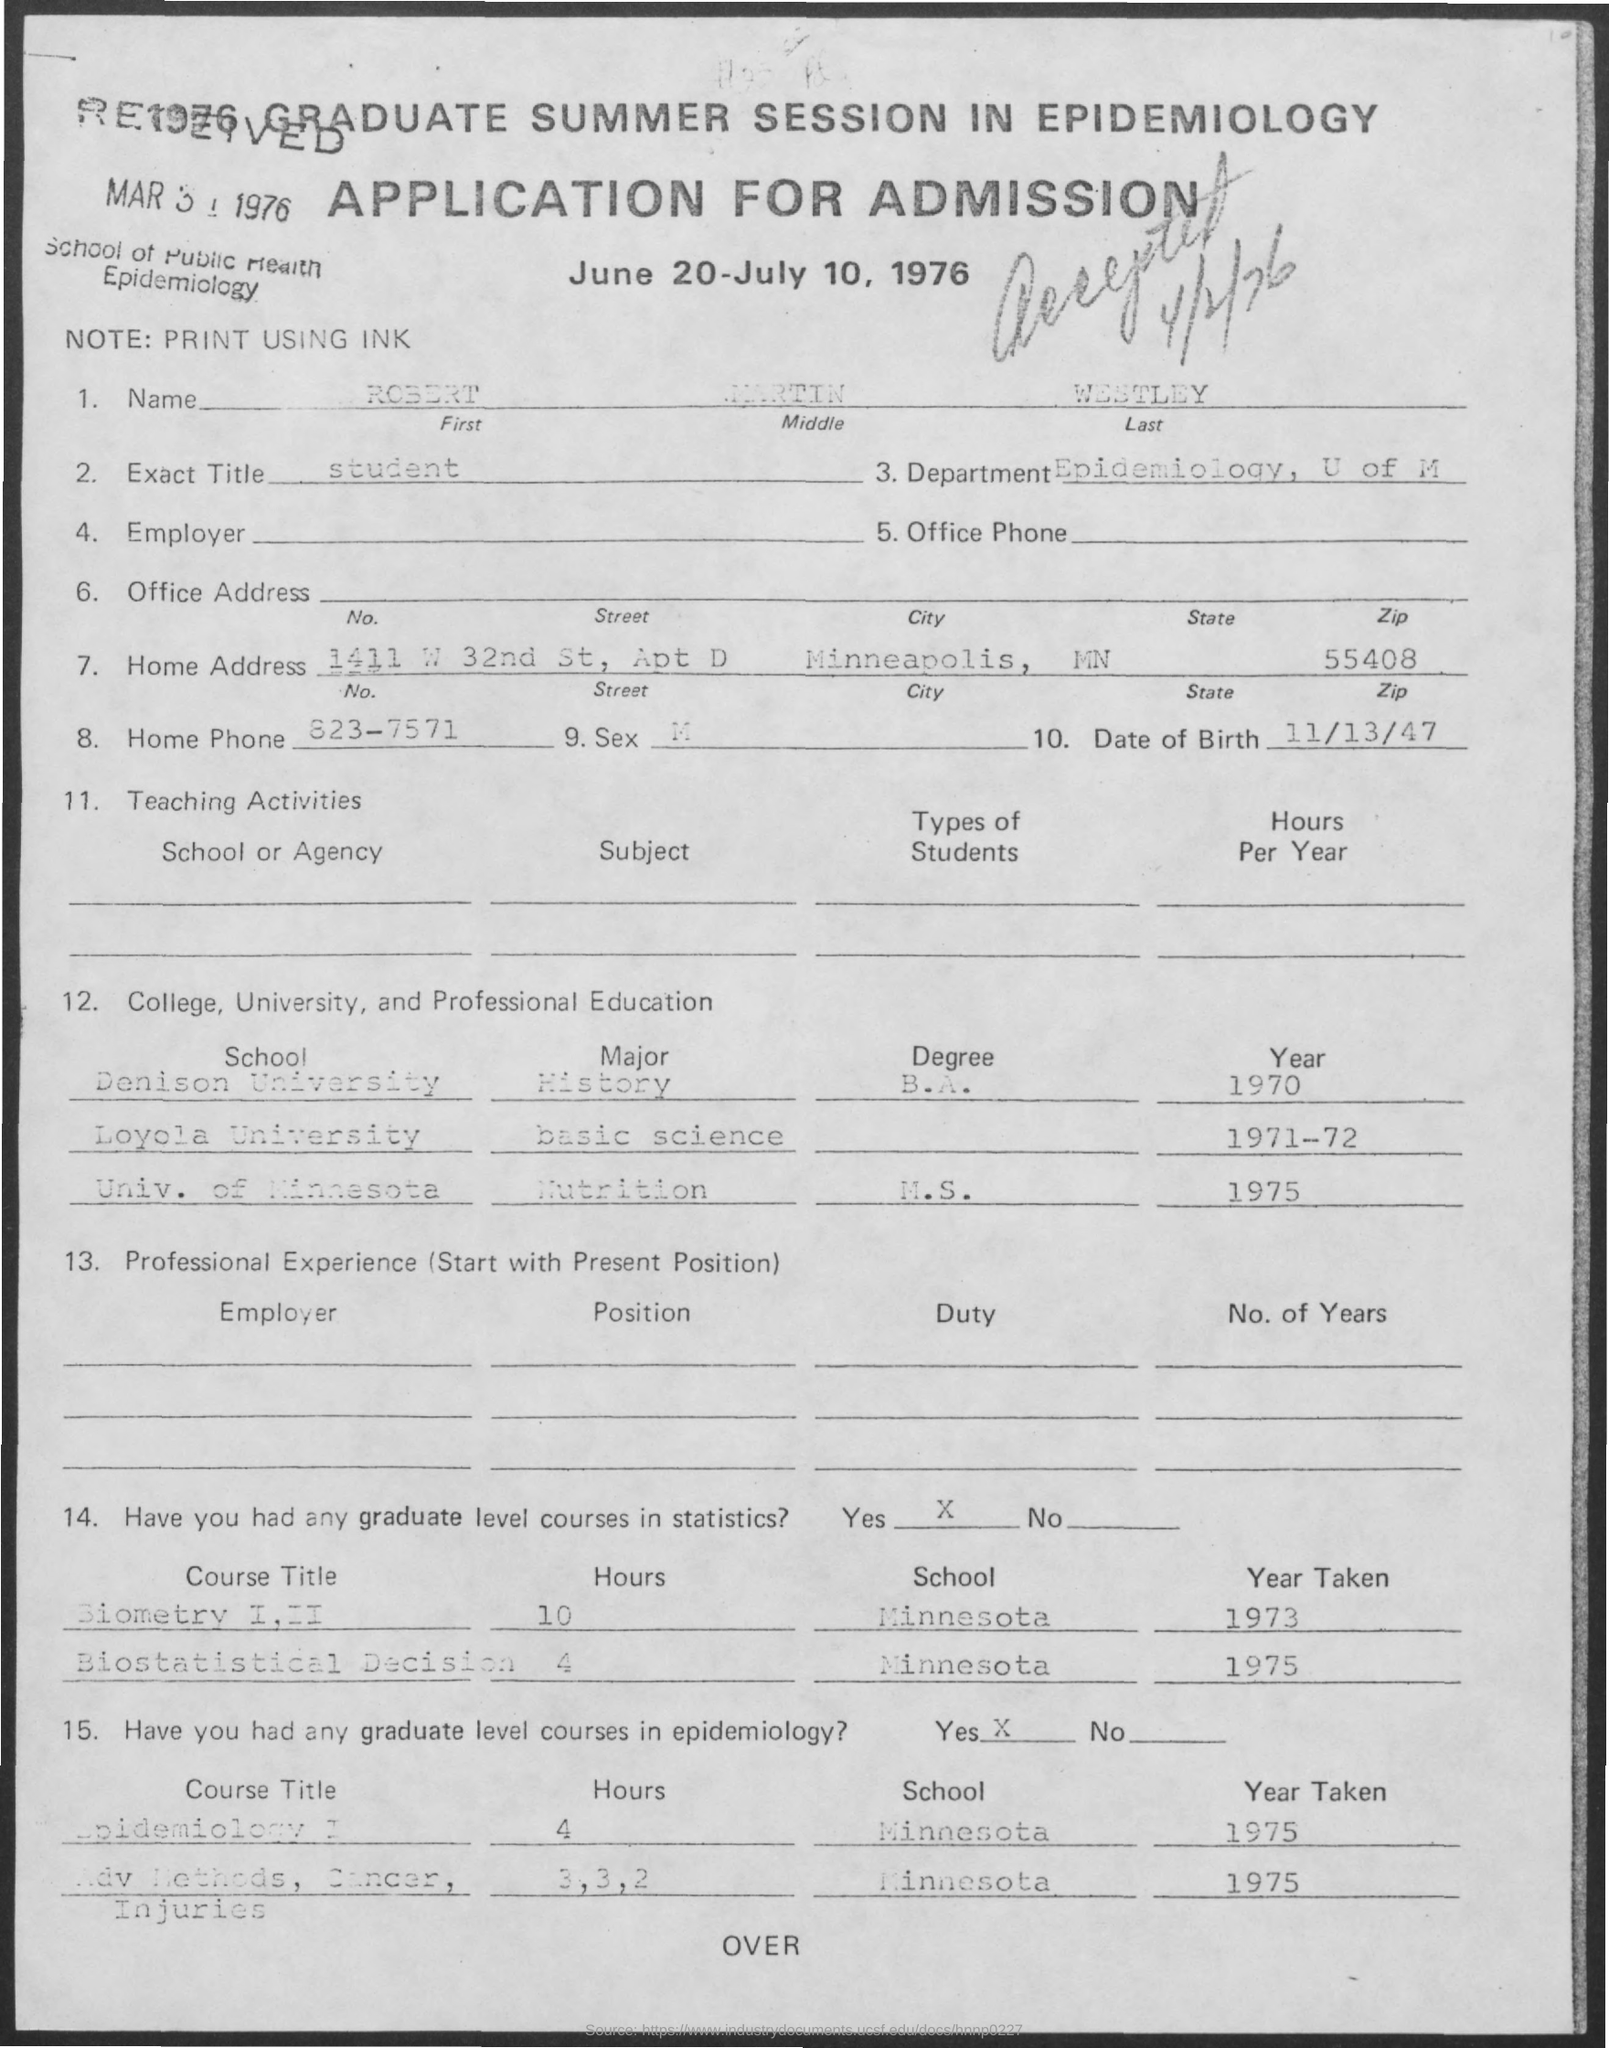what is the name mentioned ?
 Robert Martin Westley 